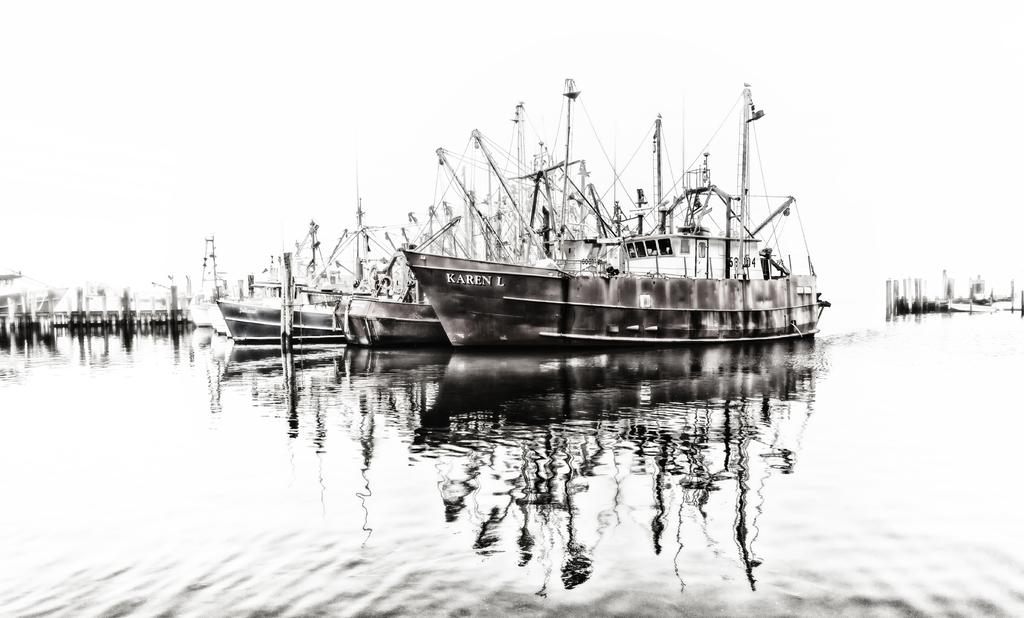What is the color scheme of the image? The image is black and white. What can be seen on the water in the image? There are ships on the water in the image. What type of material is used for the ropes in the image? The ropes in the image are made of a material that appears to be metal. What is visible above the ships in the image? The sky is visible in the image. How much sugar is present in the image? There is no sugar present in the image; it features ships on the water, ropes, metal objects, and a sky. 